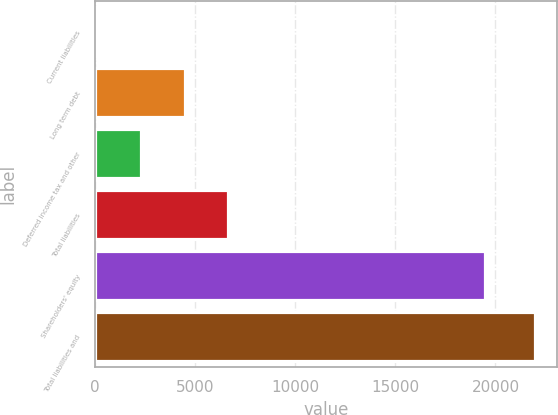<chart> <loc_0><loc_0><loc_500><loc_500><bar_chart><fcel>Current liabilities<fcel>Long term debt<fcel>Deferred income tax and other<fcel>Total liabilities<fcel>Shareholders' equity<fcel>Total liabilities and<nl><fcel>91<fcel>4468.2<fcel>2279.6<fcel>6656.8<fcel>19458<fcel>21977<nl></chart> 